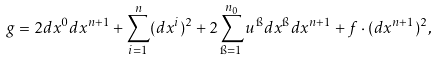<formula> <loc_0><loc_0><loc_500><loc_500>g = 2 d x ^ { 0 } d x ^ { n + 1 } + \sum ^ { n } _ { i = 1 } ( d x ^ { i } ) ^ { 2 } + 2 \sum ^ { n _ { 0 } } _ { \i = 1 } u ^ { \i } d x ^ { \i } d x ^ { n + 1 } + f \cdot ( d x ^ { n + 1 } ) ^ { 2 } ,</formula> 